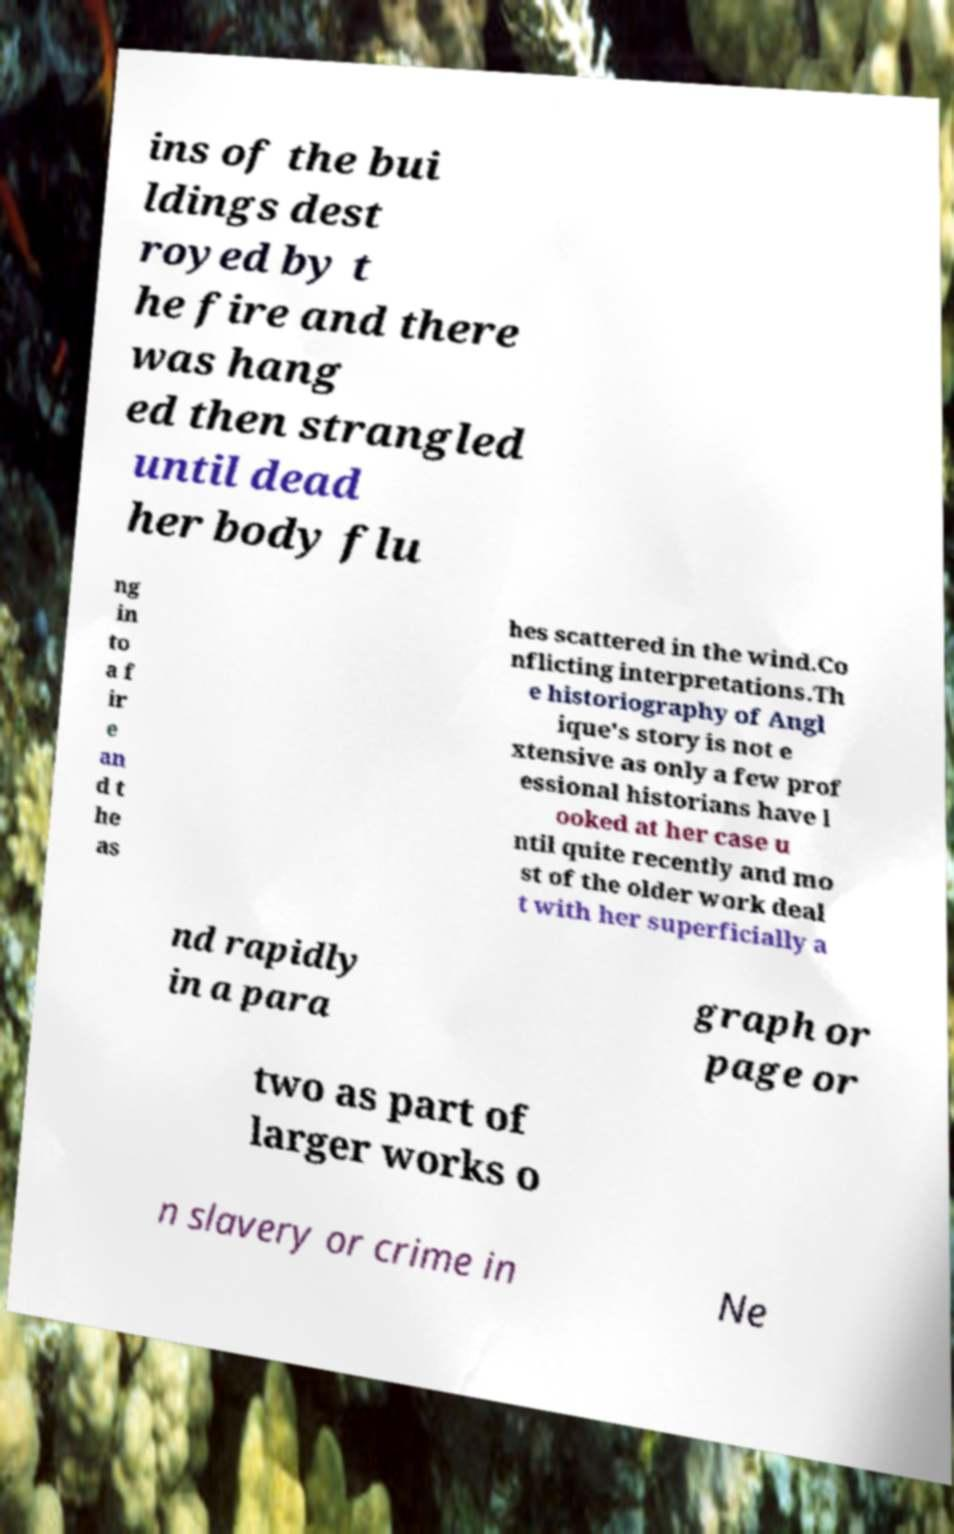Please identify and transcribe the text found in this image. ins of the bui ldings dest royed by t he fire and there was hang ed then strangled until dead her body flu ng in to a f ir e an d t he as hes scattered in the wind.Co nflicting interpretations.Th e historiography of Angl ique's story is not e xtensive as only a few prof essional historians have l ooked at her case u ntil quite recently and mo st of the older work deal t with her superficially a nd rapidly in a para graph or page or two as part of larger works o n slavery or crime in Ne 